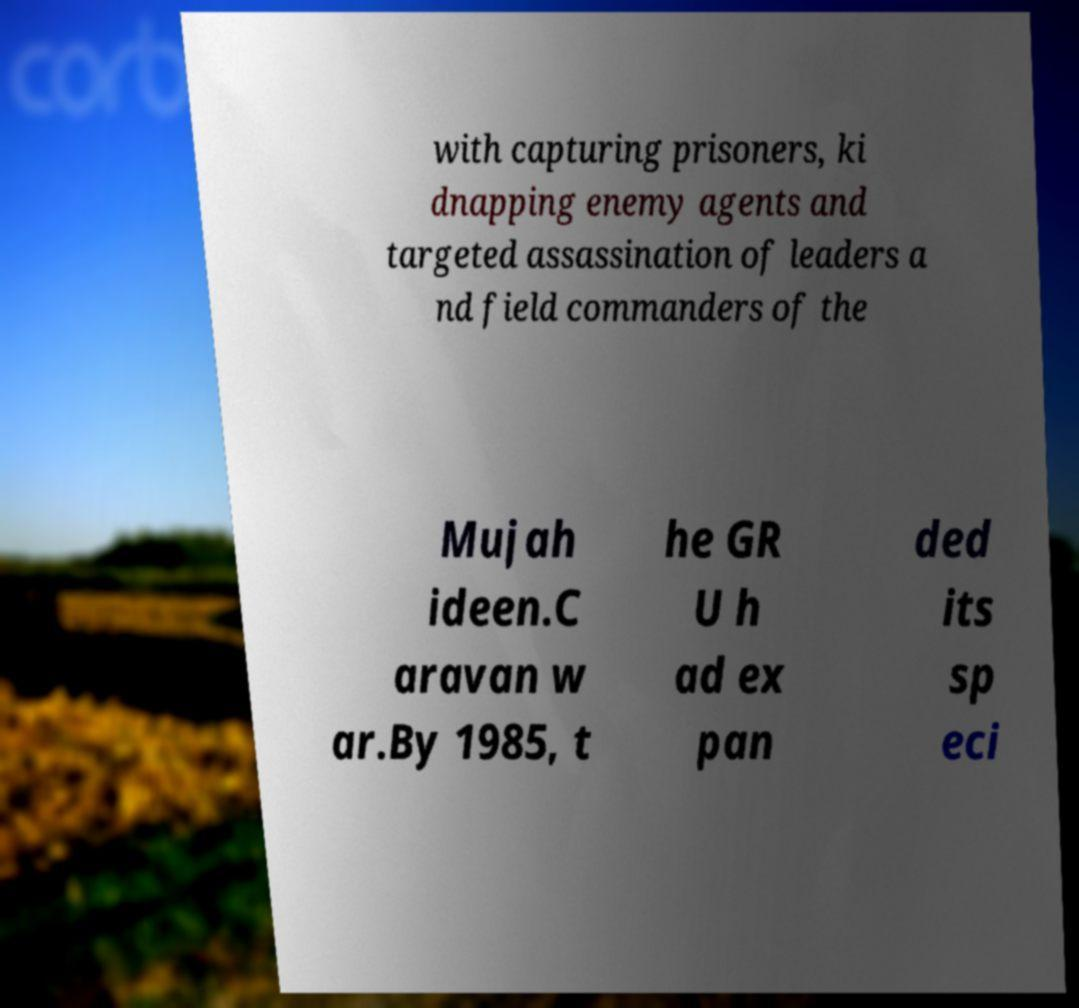Could you assist in decoding the text presented in this image and type it out clearly? with capturing prisoners, ki dnapping enemy agents and targeted assassination of leaders a nd field commanders of the Mujah ideen.C aravan w ar.By 1985, t he GR U h ad ex pan ded its sp eci 